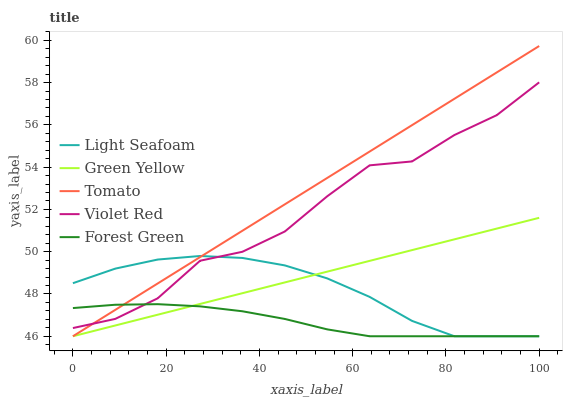Does Forest Green have the minimum area under the curve?
Answer yes or no. Yes. Does Tomato have the maximum area under the curve?
Answer yes or no. Yes. Does Green Yellow have the minimum area under the curve?
Answer yes or no. No. Does Green Yellow have the maximum area under the curve?
Answer yes or no. No. Is Tomato the smoothest?
Answer yes or no. Yes. Is Violet Red the roughest?
Answer yes or no. Yes. Is Green Yellow the smoothest?
Answer yes or no. No. Is Green Yellow the roughest?
Answer yes or no. No. Does Tomato have the lowest value?
Answer yes or no. Yes. Does Violet Red have the lowest value?
Answer yes or no. No. Does Tomato have the highest value?
Answer yes or no. Yes. Does Green Yellow have the highest value?
Answer yes or no. No. Is Green Yellow less than Violet Red?
Answer yes or no. Yes. Is Violet Red greater than Green Yellow?
Answer yes or no. Yes. Does Violet Red intersect Forest Green?
Answer yes or no. Yes. Is Violet Red less than Forest Green?
Answer yes or no. No. Is Violet Red greater than Forest Green?
Answer yes or no. No. Does Green Yellow intersect Violet Red?
Answer yes or no. No. 